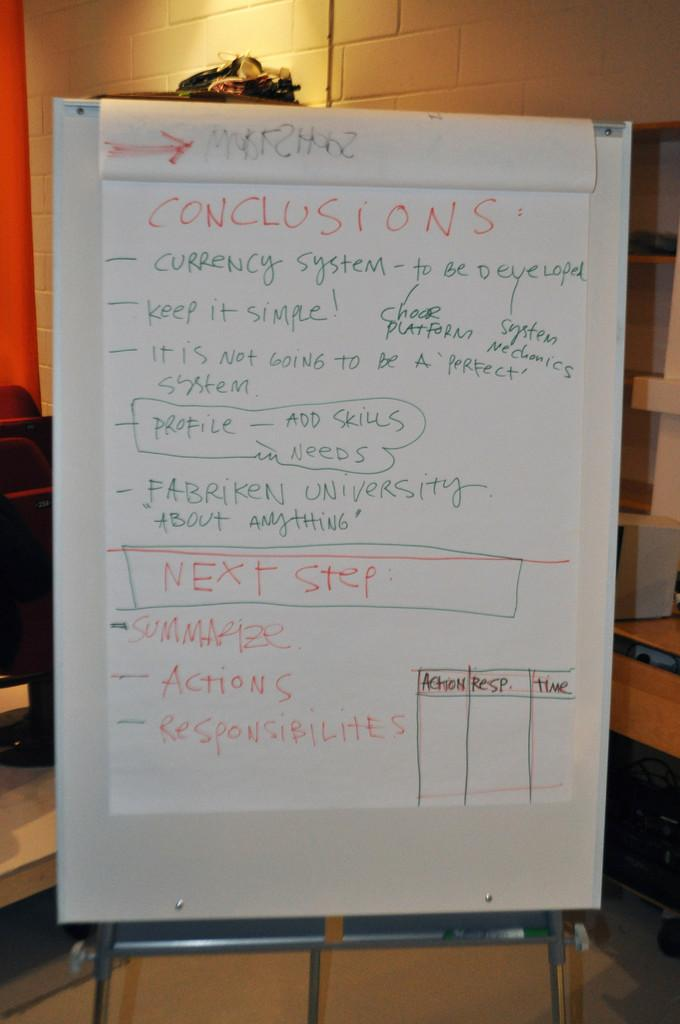<image>
Render a clear and concise summary of the photo. A large pad on an easel with details on Conclusions and the Next Step. 